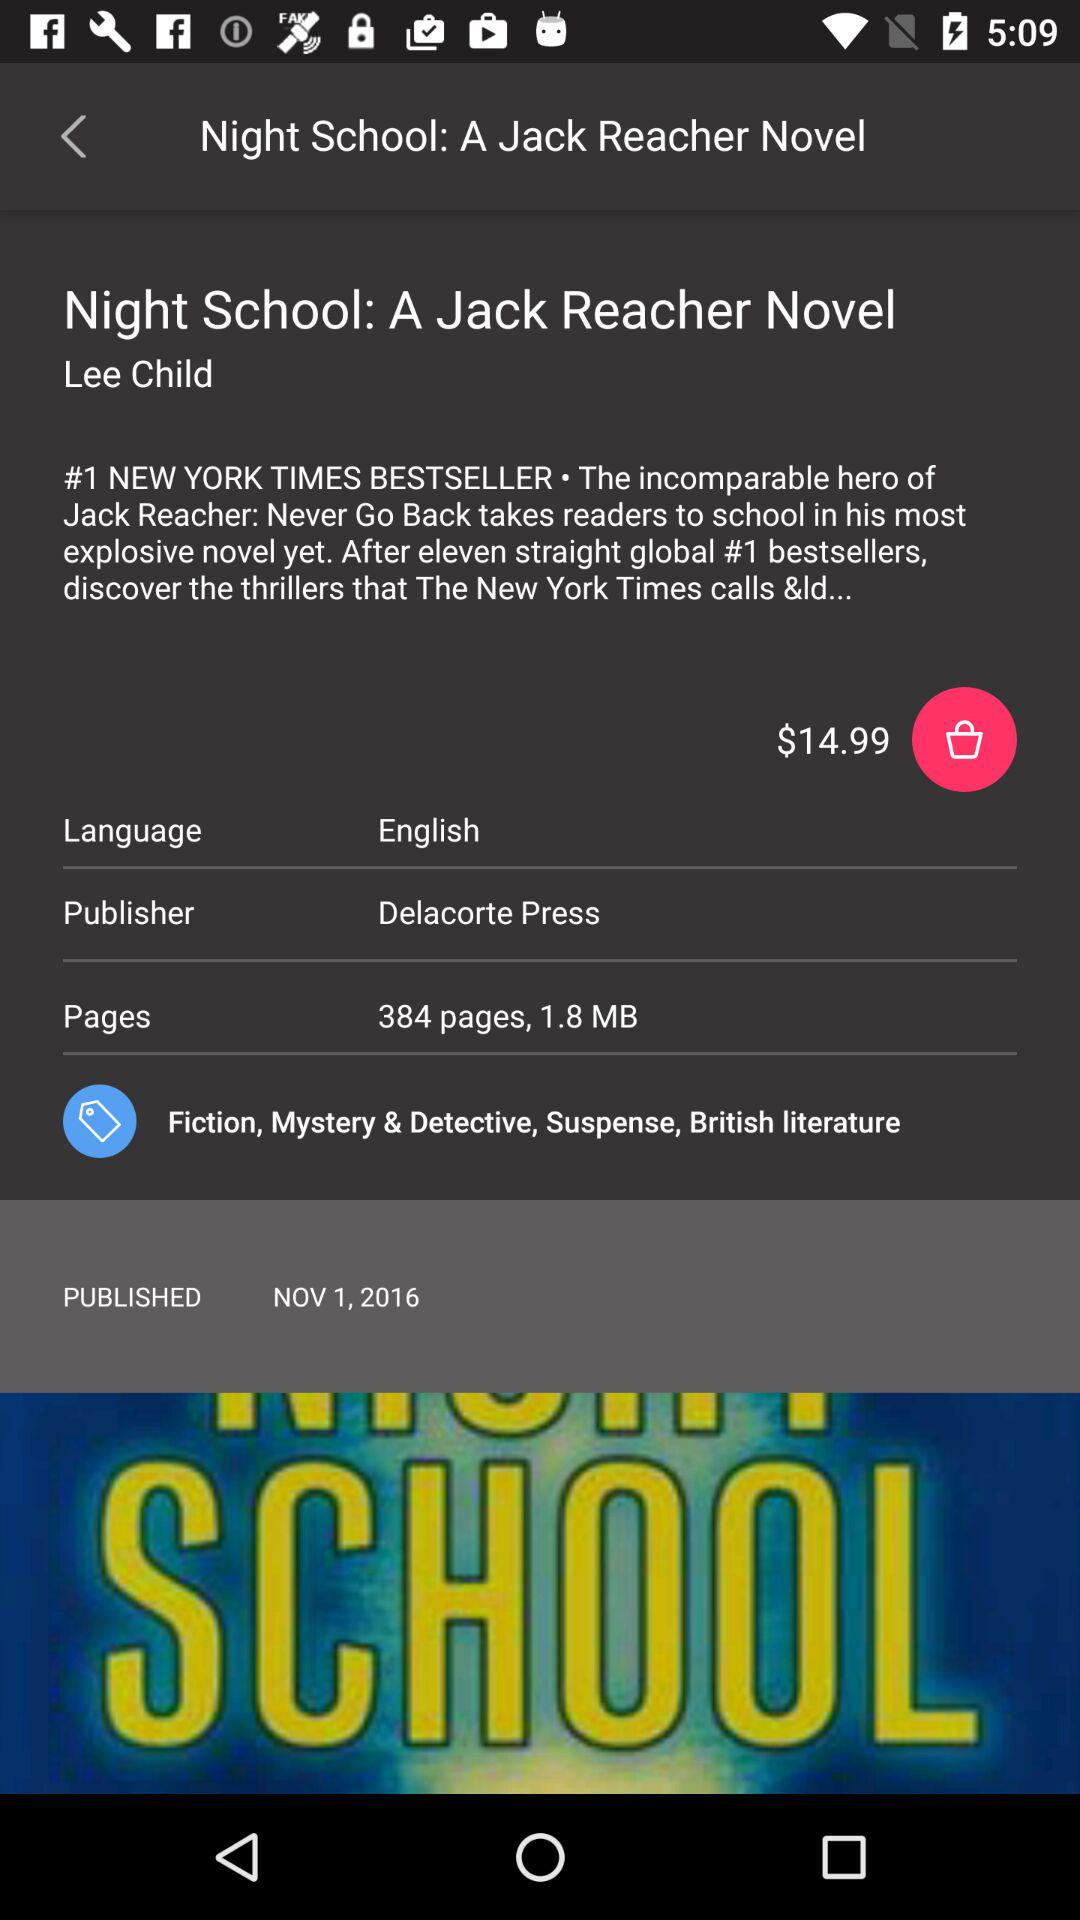What is the genre of the novel? The genres of the novel are "Fiction", "Mystery & Detective" and "Suspense". 